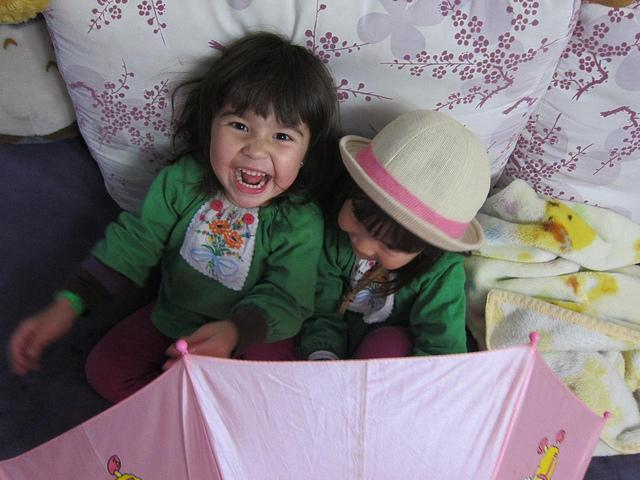What does it look like these girls are? Please explain your reasoning. twins. They are dressed alike 